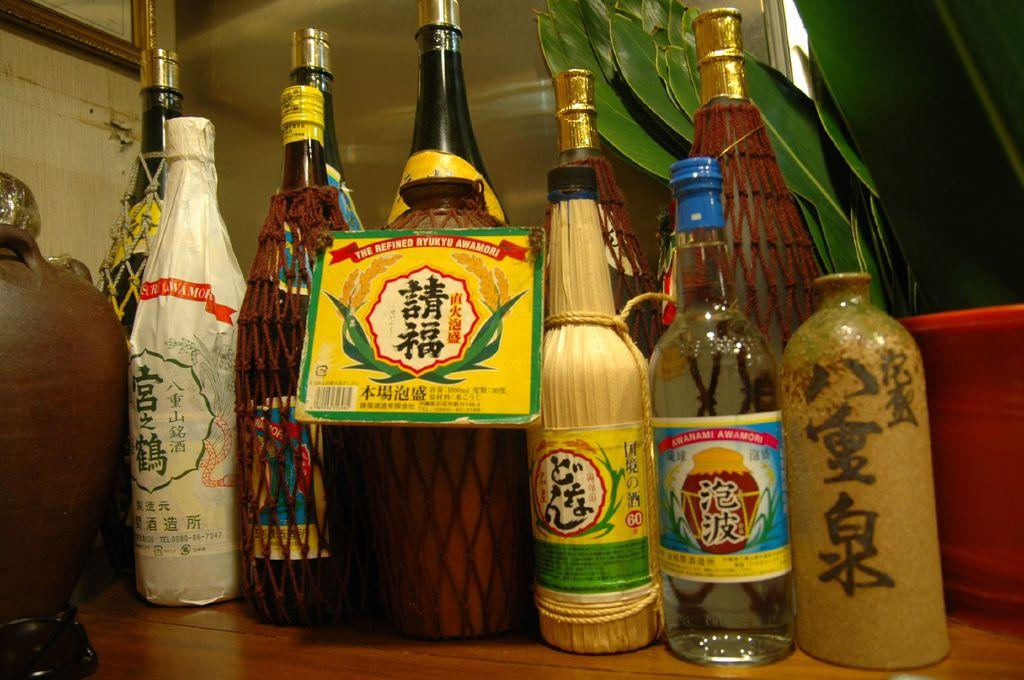<image>
Share a concise interpretation of the image provided. Several bottles of liquid with foreign characters on them, one of them says Awanami Awamori as well. 